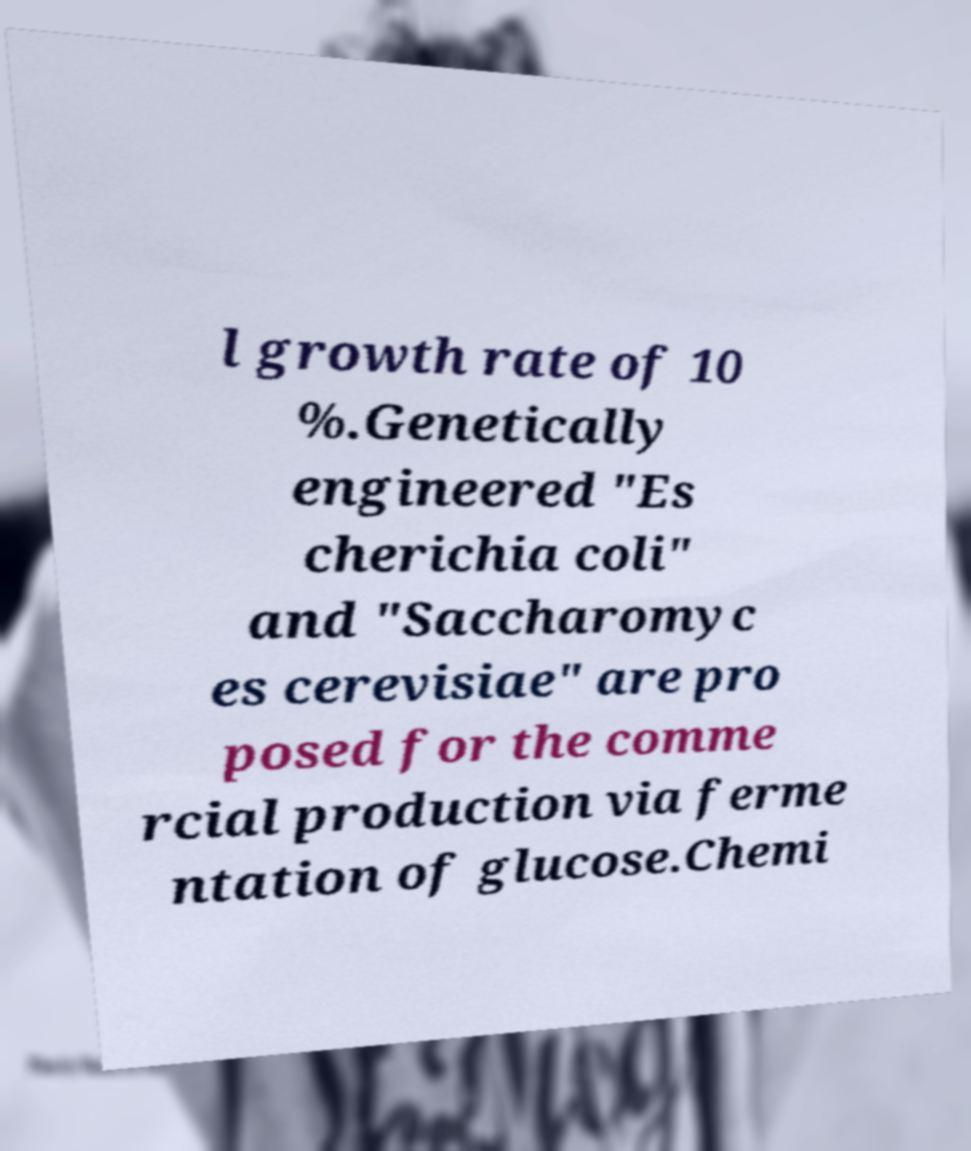Please identify and transcribe the text found in this image. l growth rate of 10 %.Genetically engineered "Es cherichia coli" and "Saccharomyc es cerevisiae" are pro posed for the comme rcial production via ferme ntation of glucose.Chemi 